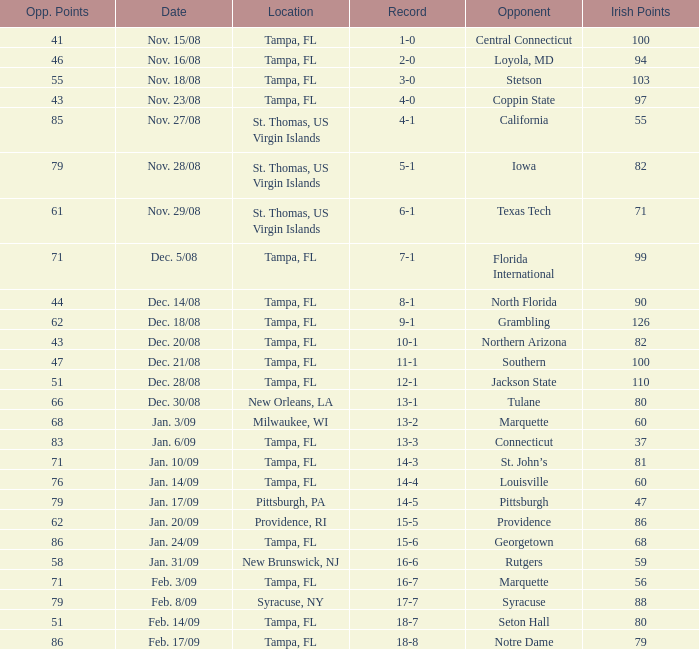What is the record where the locaiton is tampa, fl and the opponent is louisville? 14-4. 